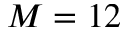Convert formula to latex. <formula><loc_0><loc_0><loc_500><loc_500>M = 1 2</formula> 